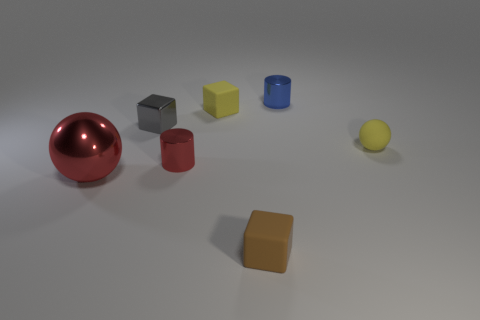Is there any other thing that has the same size as the red sphere?
Your answer should be compact. No. There is a gray shiny block; are there any matte things on the right side of it?
Provide a succinct answer. Yes. What shape is the gray metal object that is the same size as the brown matte cube?
Your answer should be very brief. Cube. Is the blue cylinder made of the same material as the large red ball?
Your answer should be compact. Yes. How many metallic things are tiny blue things or cubes?
Keep it short and to the point. 2. The metal object that is the same color as the big shiny ball is what shape?
Provide a succinct answer. Cylinder. Does the small metallic cylinder in front of the blue object have the same color as the large metal sphere?
Provide a short and direct response. Yes. What shape is the yellow thing that is in front of the yellow thing that is left of the tiny yellow rubber sphere?
Provide a succinct answer. Sphere. How many things are either small yellow objects to the left of the brown rubber cube or tiny yellow matte things that are behind the tiny yellow matte sphere?
Ensure brevity in your answer.  1. What shape is the tiny red object that is the same material as the small blue thing?
Your response must be concise. Cylinder. 